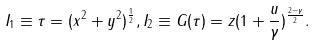Convert formula to latex. <formula><loc_0><loc_0><loc_500><loc_500>I _ { 1 } \equiv \tau = ( x ^ { 2 } + y ^ { 2 } ) ^ { \frac { 1 } { 2 } } , I _ { 2 } \equiv G ( \tau ) = z ( 1 + \frac { u } { \gamma } ) ^ { \frac { 2 - \gamma } { 2 } } .</formula> 